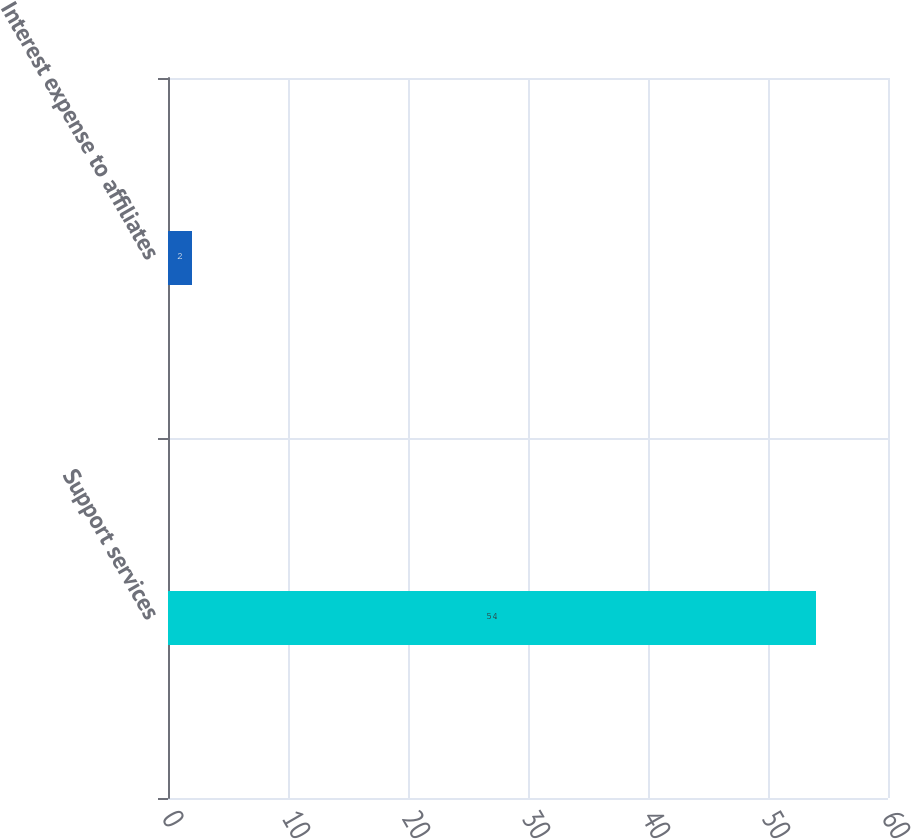Convert chart to OTSL. <chart><loc_0><loc_0><loc_500><loc_500><bar_chart><fcel>Support services<fcel>Interest expense to affiliates<nl><fcel>54<fcel>2<nl></chart> 